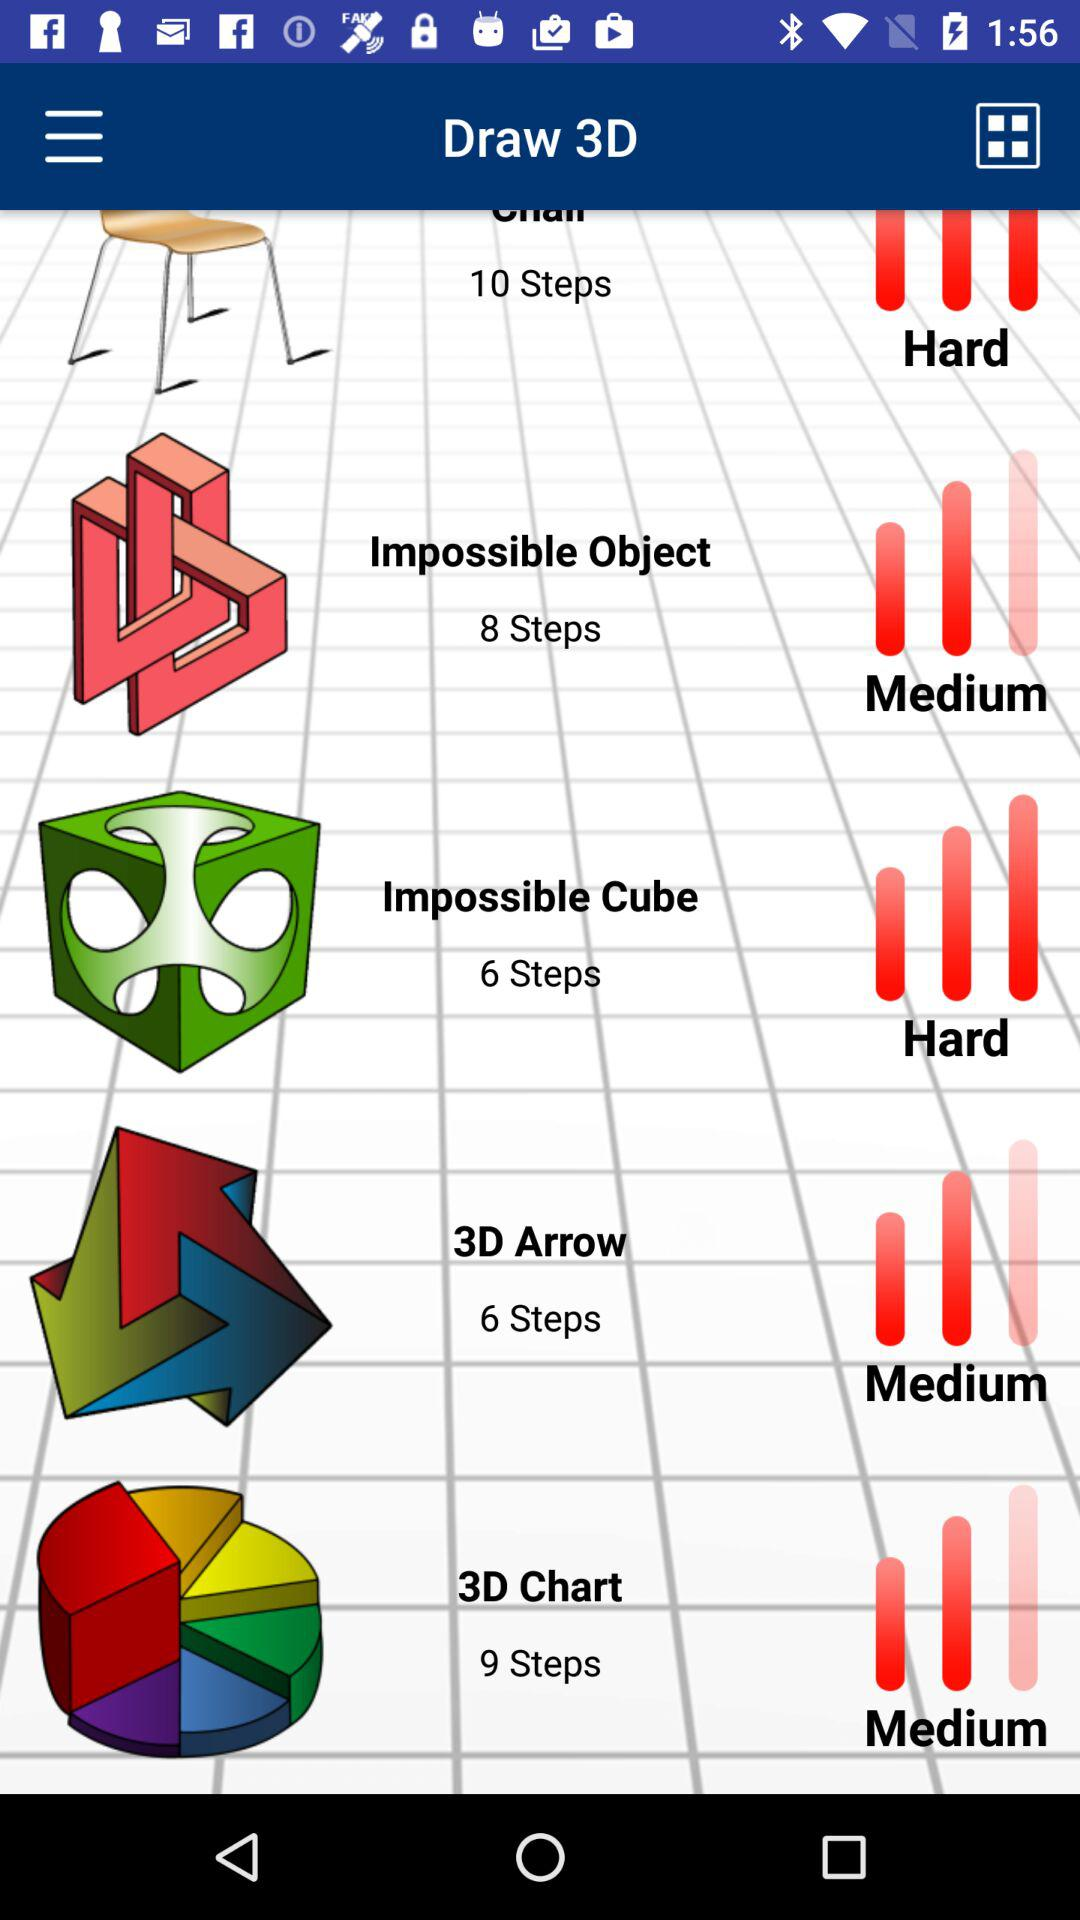How many items have a difficulty of medium?
Answer the question using a single word or phrase. 3 